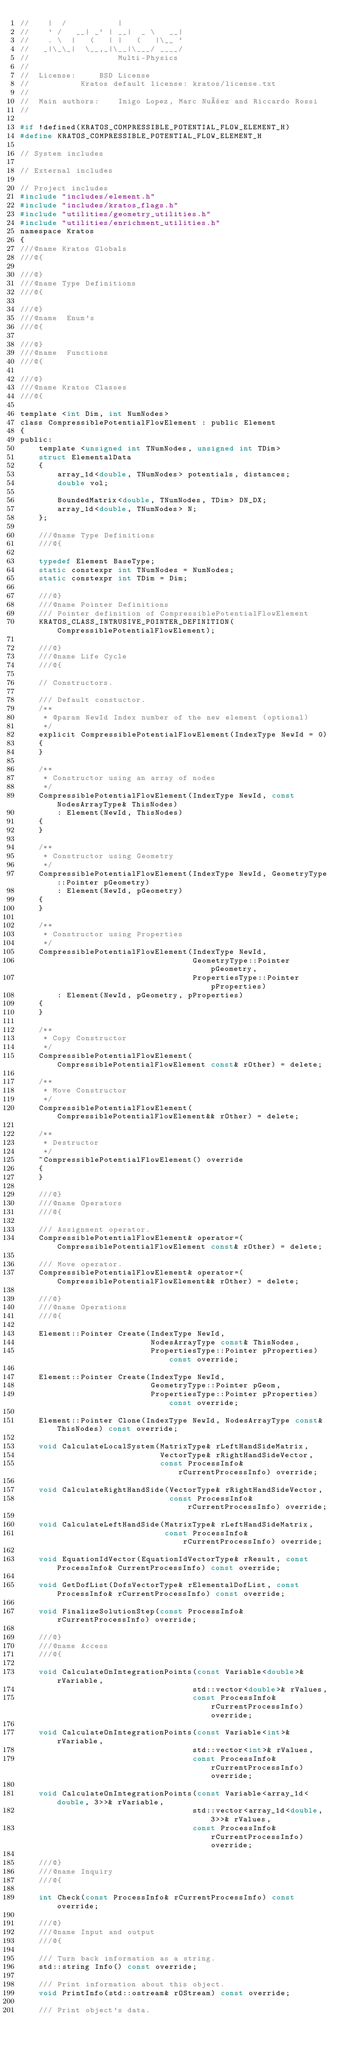Convert code to text. <code><loc_0><loc_0><loc_500><loc_500><_C_>//    |  /           |
//    ' /   __| _` | __|  _ \   __|
//    . \  |   (   | |   (   |\__ `
//   _|\_\_|  \__,_|\__|\___/ ____/
//                   Multi-Physics
//
//  License:		 BSD License
//					 Kratos default license: kratos/license.txt
//
//  Main authors:    Inigo Lopez, Marc Nuñez and Riccardo Rossi
//

#if !defined(KRATOS_COMPRESSIBLE_POTENTIAL_FLOW_ELEMENT_H)
#define KRATOS_COMPRESSIBLE_POTENTIAL_FLOW_ELEMENT_H

// System includes

// External includes

// Project includes
#include "includes/element.h"
#include "includes/kratos_flags.h"
#include "utilities/geometry_utilities.h"
#include "utilities/enrichment_utilities.h"
namespace Kratos
{
///@name Kratos Globals
///@{

///@}
///@name Type Definitions
///@{

///@}
///@name  Enum's
///@{

///@}
///@name  Functions
///@{

///@}
///@name Kratos Classes
///@{

template <int Dim, int NumNodes>
class CompressiblePotentialFlowElement : public Element
{
public:
    template <unsigned int TNumNodes, unsigned int TDim>
    struct ElementalData
    {
        array_1d<double, TNumNodes> potentials, distances;
        double vol;

        BoundedMatrix<double, TNumNodes, TDim> DN_DX;
        array_1d<double, TNumNodes> N;
    };

    ///@name Type Definitions
    ///@{

    typedef Element BaseType;
    static constexpr int TNumNodes = NumNodes;
    static constexpr int TDim = Dim;

    ///@}
    ///@name Pointer Definitions
    /// Pointer definition of CompressiblePotentialFlowElement
    KRATOS_CLASS_INTRUSIVE_POINTER_DEFINITION(CompressiblePotentialFlowElement);

    ///@}
    ///@name Life Cycle
    ///@{

    // Constructors.

    /// Default constuctor.
    /**
     * @param NewId Index number of the new element (optional)
     */
    explicit CompressiblePotentialFlowElement(IndexType NewId = 0)
    {
    }

    /**
     * Constructor using an array of nodes
     */
    CompressiblePotentialFlowElement(IndexType NewId, const NodesArrayType& ThisNodes)
        : Element(NewId, ThisNodes)
    {
    }

    /**
     * Constructor using Geometry
     */
    CompressiblePotentialFlowElement(IndexType NewId, GeometryType::Pointer pGeometry)
        : Element(NewId, pGeometry)
    {
    }

    /**
     * Constructor using Properties
     */
    CompressiblePotentialFlowElement(IndexType NewId,
                                     GeometryType::Pointer pGeometry,
                                     PropertiesType::Pointer pProperties)
        : Element(NewId, pGeometry, pProperties)
    {
    }

    /**
     * Copy Constructor
     */
    CompressiblePotentialFlowElement(CompressiblePotentialFlowElement const& rOther) = delete;

    /**
     * Move Constructor
     */
    CompressiblePotentialFlowElement(CompressiblePotentialFlowElement&& rOther) = delete;

    /**
     * Destructor
     */
    ~CompressiblePotentialFlowElement() override
    {
    }

    ///@}
    ///@name Operators
    ///@{

    /// Assignment operator.
    CompressiblePotentialFlowElement& operator=(CompressiblePotentialFlowElement const& rOther) = delete;

    /// Move operator.
    CompressiblePotentialFlowElement& operator=(CompressiblePotentialFlowElement&& rOther) = delete;

    ///@}
    ///@name Operations
    ///@{

    Element::Pointer Create(IndexType NewId,
                            NodesArrayType const& ThisNodes,
                            PropertiesType::Pointer pProperties) const override;

    Element::Pointer Create(IndexType NewId,
                            GeometryType::Pointer pGeom,
                            PropertiesType::Pointer pProperties) const override;

    Element::Pointer Clone(IndexType NewId, NodesArrayType const& ThisNodes) const override;

    void CalculateLocalSystem(MatrixType& rLeftHandSideMatrix,
                              VectorType& rRightHandSideVector,
                              const ProcessInfo& rCurrentProcessInfo) override;

    void CalculateRightHandSide(VectorType& rRightHandSideVector,
                                const ProcessInfo& rCurrentProcessInfo) override;

    void CalculateLeftHandSide(MatrixType& rLeftHandSideMatrix,
                               const ProcessInfo& rCurrentProcessInfo) override;

    void EquationIdVector(EquationIdVectorType& rResult, const ProcessInfo& CurrentProcessInfo) const override;

    void GetDofList(DofsVectorType& rElementalDofList, const ProcessInfo& rCurrentProcessInfo) const override;

    void FinalizeSolutionStep(const ProcessInfo& rCurrentProcessInfo) override;

    ///@}
    ///@name Access
    ///@{

    void CalculateOnIntegrationPoints(const Variable<double>& rVariable,
                                     std::vector<double>& rValues,
                                     const ProcessInfo& rCurrentProcessInfo) override;

    void CalculateOnIntegrationPoints(const Variable<int>& rVariable,
                                     std::vector<int>& rValues,
                                     const ProcessInfo& rCurrentProcessInfo) override;

    void CalculateOnIntegrationPoints(const Variable<array_1d<double, 3>>& rVariable,
                                     std::vector<array_1d<double, 3>>& rValues,
                                     const ProcessInfo& rCurrentProcessInfo) override;

    ///@}
    ///@name Inquiry
    ///@{

    int Check(const ProcessInfo& rCurrentProcessInfo) const override;

    ///@}
    ///@name Input and output
    ///@{

    /// Turn back information as a string.
    std::string Info() const override;

    /// Print information about this object.
    void PrintInfo(std::ostream& rOStream) const override;

    /// Print object's data.</code> 